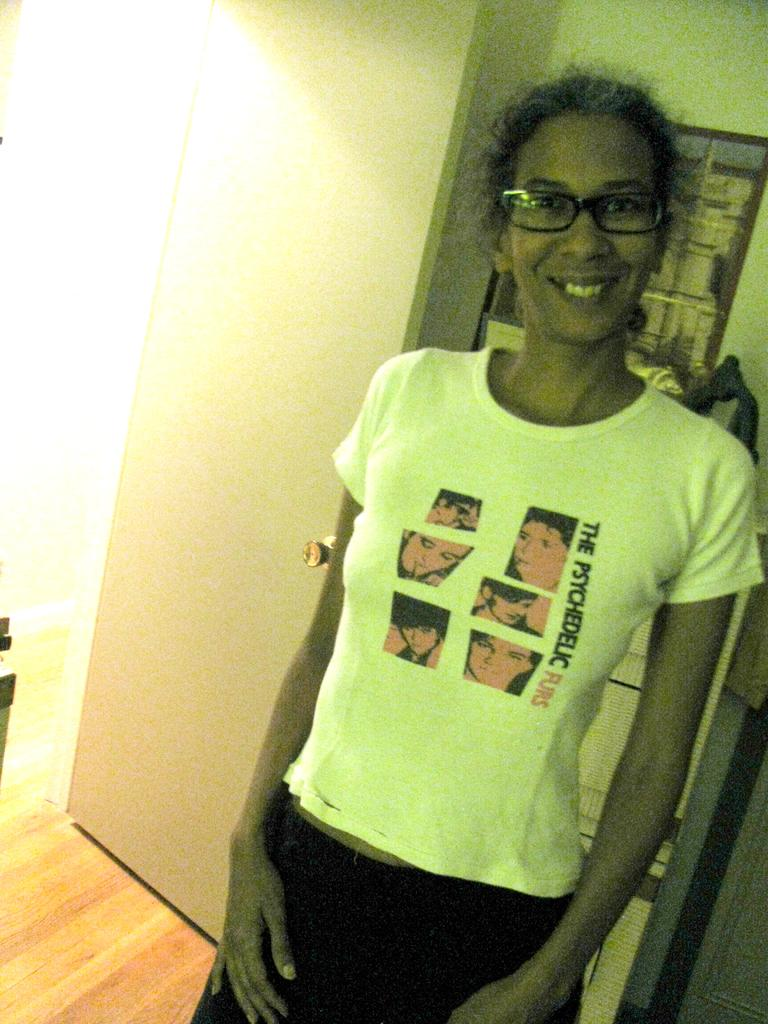Who is present in the image? There is a woman in the image. What is the woman wearing? The woman is wearing a white T-shirt. What accessory is the woman wearing? The woman is wearing spectacles. What is the woman doing in the image? The woman is standing and smiling. What type of flooring is visible in the image? There is a wooden floor in the image. What architectural feature can be seen in the image? There is a door in the image. What can be seen in the background of the image? There are objects in the background of the image. How many plates are stacked on the door in the image? There are no plates visible on the door in the image. What type of card is the woman holding in the image? The woman is not holding any card in the image. 